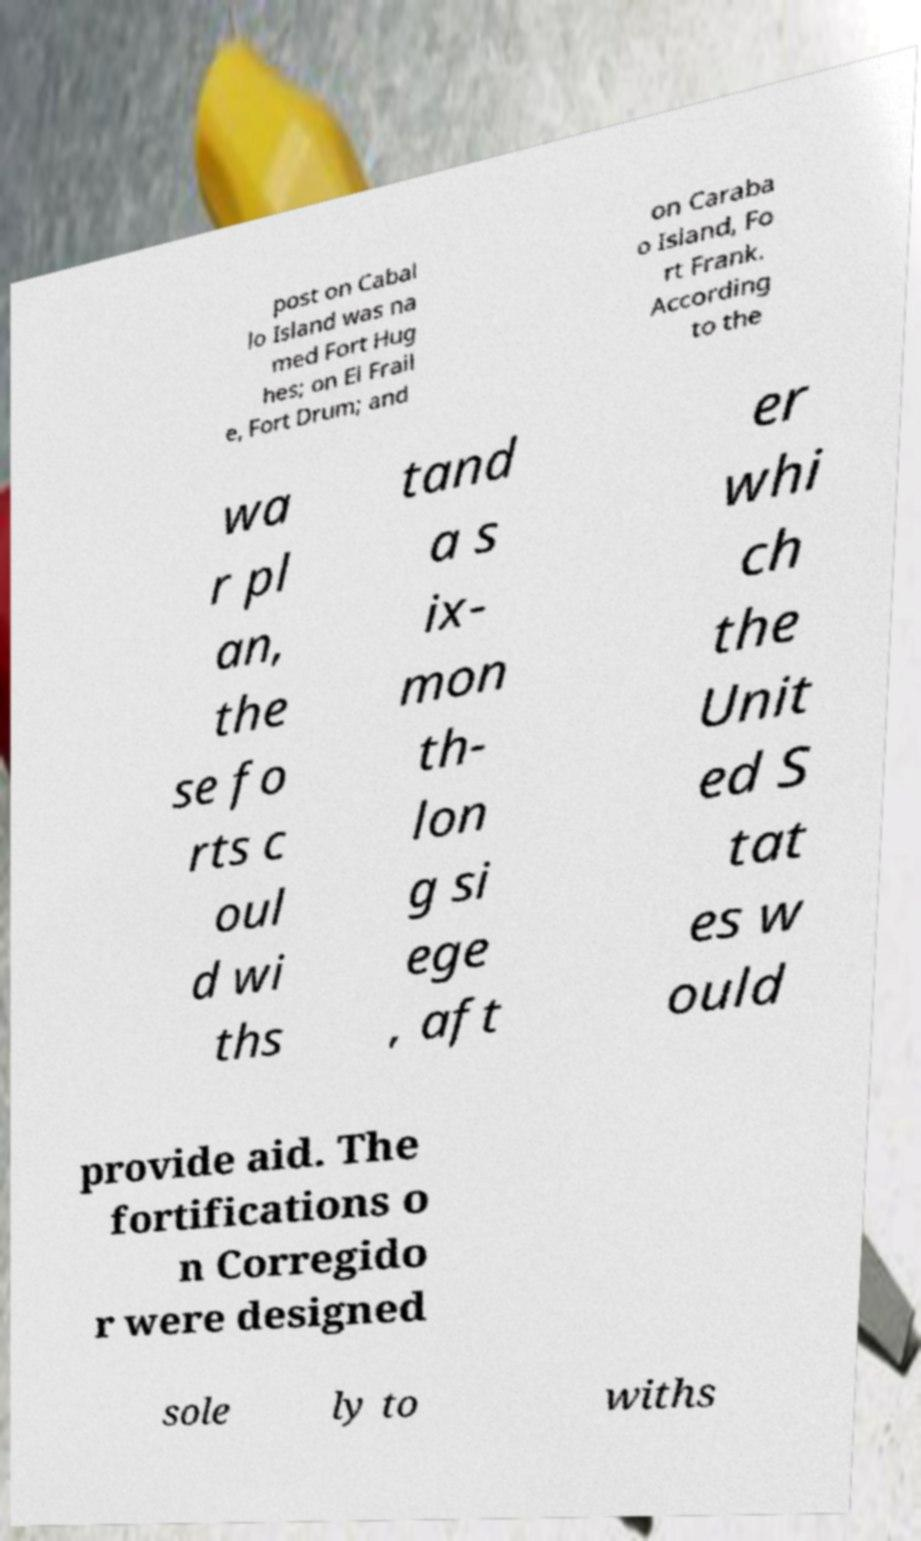I need the written content from this picture converted into text. Can you do that? post on Cabal lo Island was na med Fort Hug hes; on El Frail e, Fort Drum; and on Caraba o Island, Fo rt Frank. According to the wa r pl an, the se fo rts c oul d wi ths tand a s ix- mon th- lon g si ege , aft er whi ch the Unit ed S tat es w ould provide aid. The fortifications o n Corregido r were designed sole ly to withs 